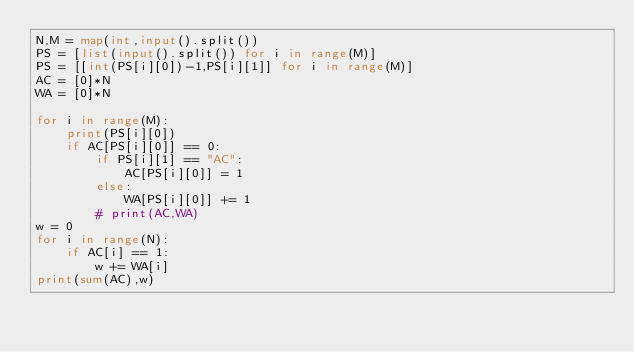<code> <loc_0><loc_0><loc_500><loc_500><_Python_>N,M = map(int,input().split())
PS = [list(input().split()) for i in range(M)]
PS = [[int(PS[i][0])-1,PS[i][1]] for i in range(M)]
AC = [0]*N
WA = [0]*N

for i in range(M):
    print(PS[i][0])
    if AC[PS[i][0]] == 0:
        if PS[i][1] == "AC":
            AC[PS[i][0]] = 1
        else:
            WA[PS[i][0]] += 1
        # print(AC,WA)
w = 0
for i in range(N):
    if AC[i] == 1:
        w += WA[i]
print(sum(AC),w)
</code> 